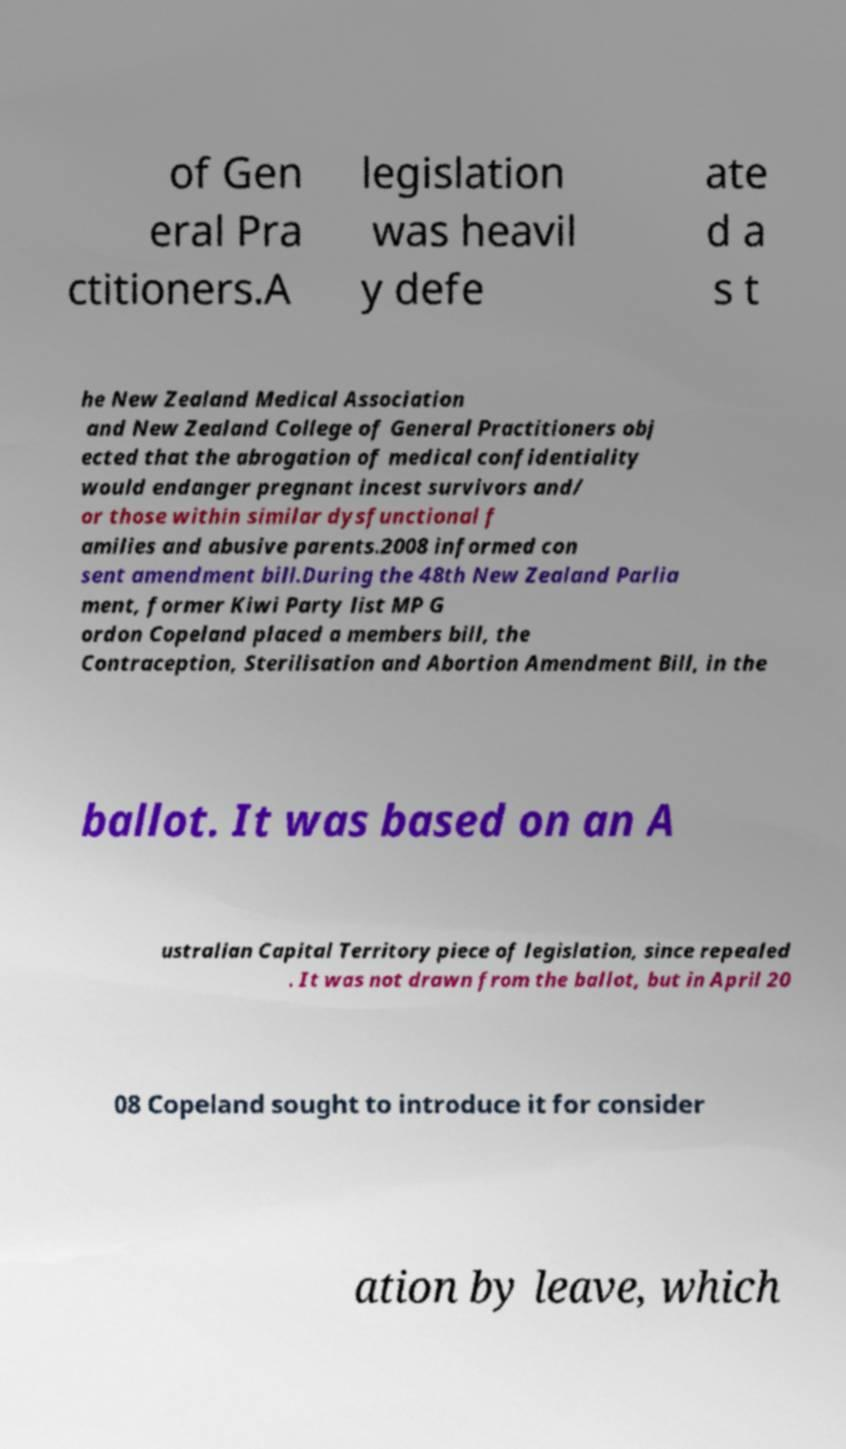Could you assist in decoding the text presented in this image and type it out clearly? of Gen eral Pra ctitioners.A legislation was heavil y defe ate d a s t he New Zealand Medical Association and New Zealand College of General Practitioners obj ected that the abrogation of medical confidentiality would endanger pregnant incest survivors and/ or those within similar dysfunctional f amilies and abusive parents.2008 informed con sent amendment bill.During the 48th New Zealand Parlia ment, former Kiwi Party list MP G ordon Copeland placed a members bill, the Contraception, Sterilisation and Abortion Amendment Bill, in the ballot. It was based on an A ustralian Capital Territory piece of legislation, since repealed . It was not drawn from the ballot, but in April 20 08 Copeland sought to introduce it for consider ation by leave, which 